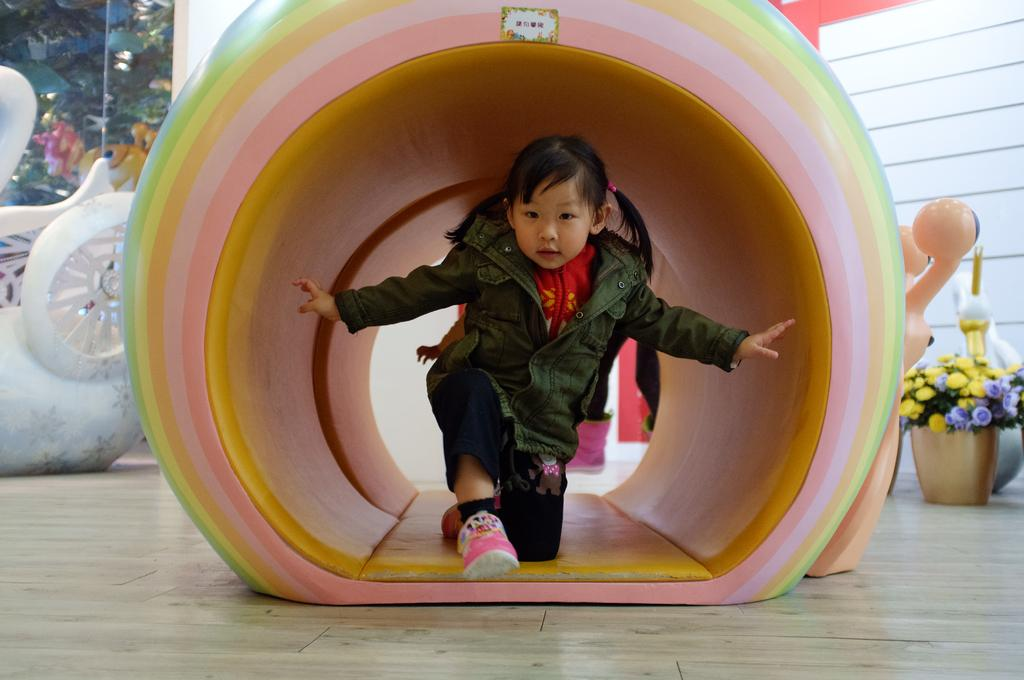What is the main subject of the image? There is a kid in the image. What can be seen in the middle of the image? There is an object in the middle of the image. What type of objects are present in the image? Flower pots are present in the image. What can be seen in the background of the image? There are trees and a wall in the background of the image. What is the kid's wish in the image? There is no indication of the kid's wish in the image. What part of the kid's brain can be seen in the image? There is no part of the kid's brain visible in the image. 